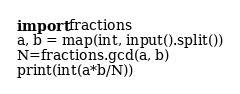Convert code to text. <code><loc_0><loc_0><loc_500><loc_500><_Python_>import fractions
a, b = map(int, input().split())
N=fractions.gcd(a, b)
print(int(a*b/N))</code> 